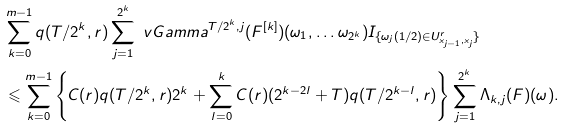<formula> <loc_0><loc_0><loc_500><loc_500>& \sum _ { k = 0 } ^ { m - 1 } q ( T / 2 ^ { k } , r ) \sum _ { j = 1 } ^ { 2 ^ { k } } \ v G a m m a ^ { T / 2 ^ { k } , j } ( F ^ { [ k ] } ) ( \omega _ { 1 } , \dots \omega _ { 2 ^ { k } } ) I _ { \{ \omega _ { j } ( 1 / 2 ) \in U _ { x _ { j - 1 } , x _ { j } } ^ { r } \} } \\ & \leqslant \sum _ { k = 0 } ^ { m - 1 } \left \{ C ( r ) q ( T / 2 ^ { k } , r ) 2 ^ { k } + \sum _ { l = 0 } ^ { k } C ( r ) ( 2 ^ { k - 2 l } + T ) q ( T / 2 ^ { k - l } , r ) \right \} \sum _ { j = 1 } ^ { 2 ^ { k } } \Lambda _ { k , j } ( F ) ( \omega ) .</formula> 